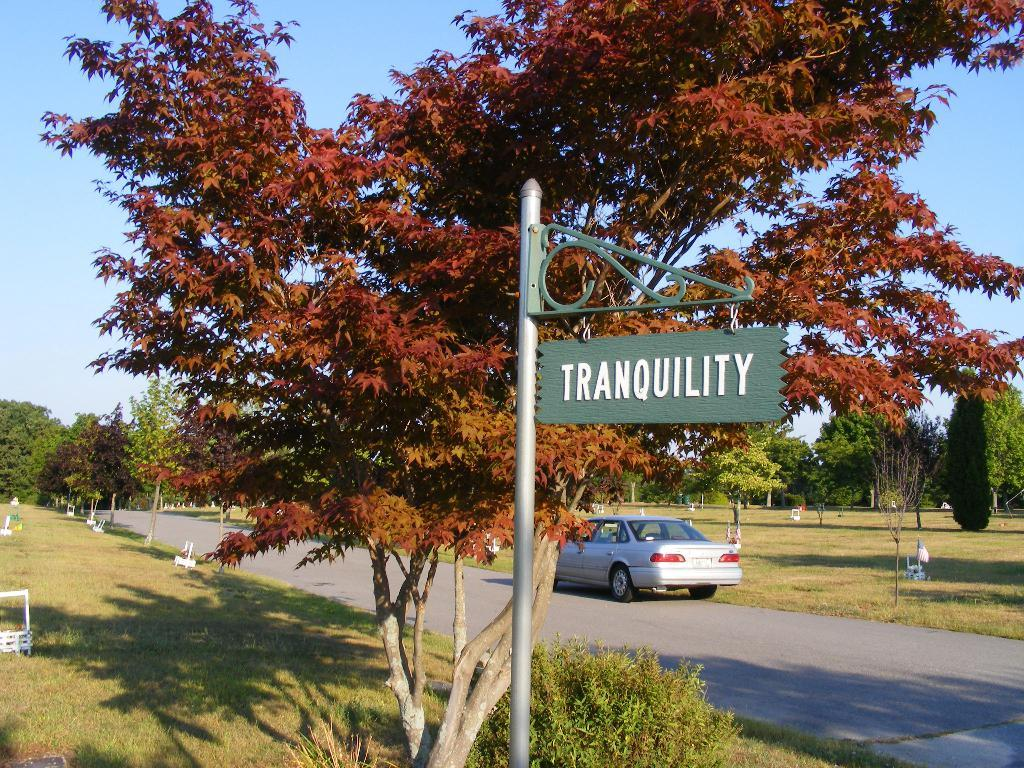What is the main feature of the image? There is a road in the image. What can be seen on both sides of the road? Trees and gardens are present on both sides of the road. Is there any vehicle visible in the image? Yes, a car is parked on the road. What is located in the center of the image? There is a pole with a sign board in the center of the image. What type of ink is used to write on the sign board in the image? There is no information about the type of ink used on the sign board in the image. Additionally, the image does not show any writing on the sign board. How many layers of polish are applied to the car in the image? There is no information about the car's paint or polish in the image. 